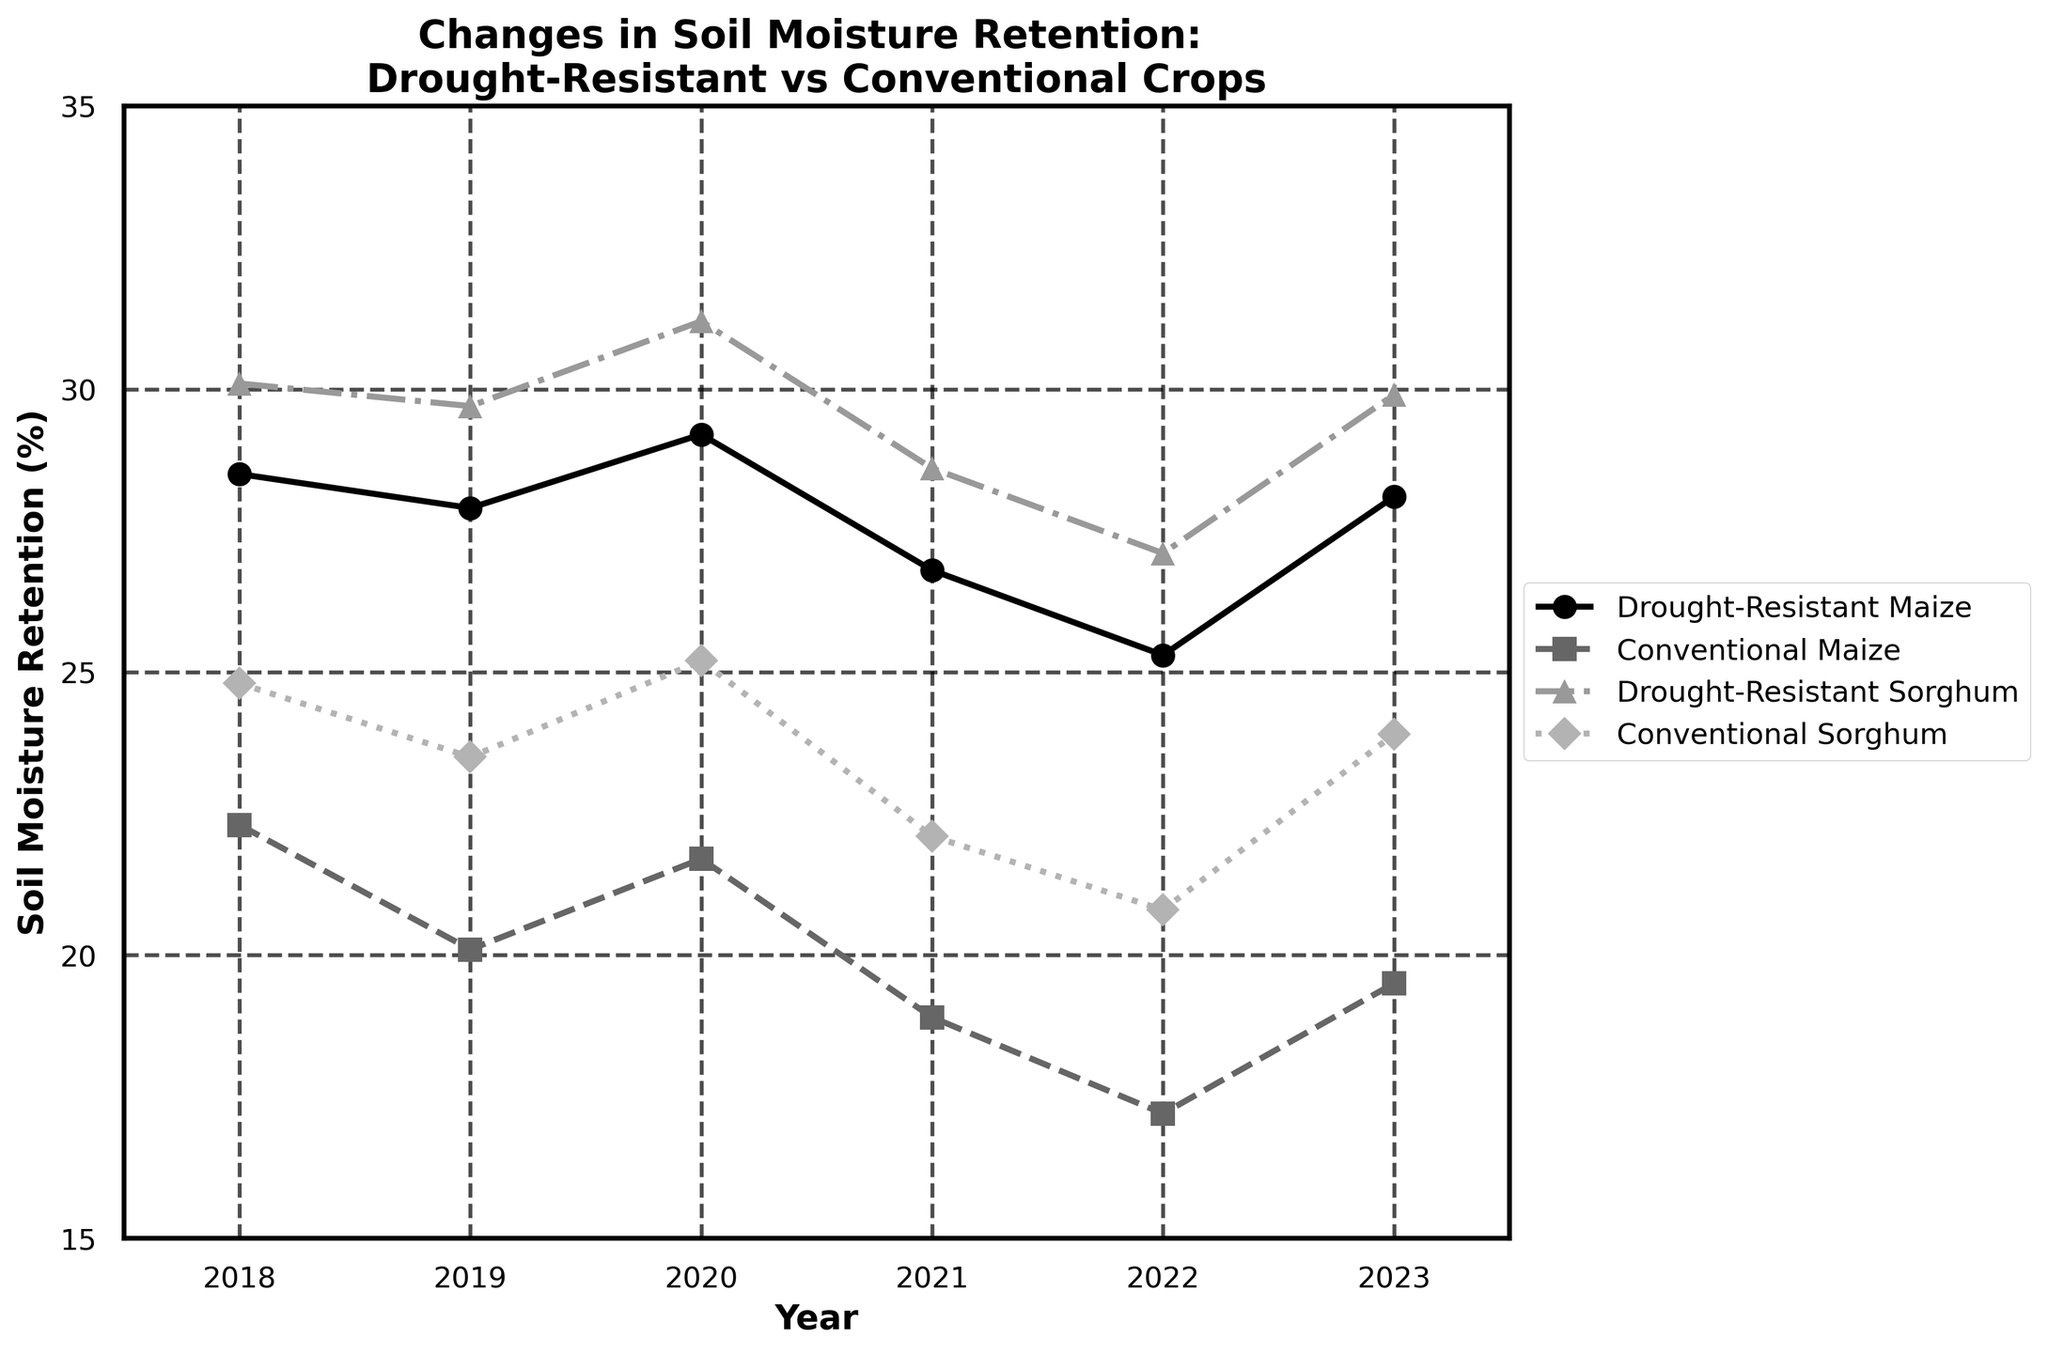What's the average soil moisture retention of Drought-Resistant Maize from 2018 to 2023? To find the average, sum all moisture retention values for Drought-Resistant Maize from 2018 to 2023 and divide by the number of years. The values are 28.5, 27.9, 29.2, 26.8, 25.3, and 28.1. Sum = 28.5 + 27.9 + 29.2 + 26.8 + 25.3 + 28.1 = 165.8. There are 6 measurements, so 165.8 / 6 = 27.63
Answer: 27.63 Which crop shows the highest soil moisture retention in 2023? Compare the 2023 values for all crops. The values are Drought-Resistant Maize (28.1), Conventional Maize (19.5), Drought-Resistant Sorghum (29.9), and Conventional Sorghum (23.9). Drought-Resistant Sorghum has the highest value.
Answer: Drought-Resistant Sorghum For which year is the difference in soil moisture retention between Drought-Resistant Maize and Conventional Maize the largest? Calculate the difference for each year, then determine the largest. Differences: 2018 (28.5 - 22.3 = 6.2), 2019 (27.9 - 20.1 = 7.8), 2020 (29.2 - 21.7 = 7.5), 2021 (26.8 - 18.9 = 7.9), 2022 (25.3 - 17.2 = 8.1), 2023 (28.1 - 19.5 = 8.6). The largest difference is in 2023.
Answer: 2023 What is the trend of soil moisture retention for Conventional Sorghum from 2018 to 2023? Analyze the values of Conventional Sorghum: 2018 (24.8), 2019 (23.5), 2020 (25.2), 2021 (22.1), 2022 (20.8), 2023 (23.9). The trend is generally decreasing from 2018 to 2022 with an increase in 2023.
Answer: Generally decreasing, then increasing in 2023 Which crop showed a decrease in soil moisture retention from 2018 to 2019? Compare 2018 and 2019 values for each crop. Drought-Resistant Maize (28.5 to 27.9), Conventional Maize (22.3 to 20.1), Drought-Resistant Sorghum (30.1 to 29.7), and Conventional Sorghum (24.8 to 23.5). All crops showed a decrease.
Answer: All crops By how much did soil moisture retention of Conventional Maize change from 2021 to 2022? Subtract the 2021 value from the 2022 value for Conventional Maize: 17.2 - 18.9 = -1.7. The retention decreased by 1.7.
Answer: Decreased by 1.7 Which year shows the highest overall soil moisture retention for all crops combined? Add all crop values for each year and find the highest sum: 2018 (105.7), 2019 (101.2), 2020 (107.3), 2021 (96.4), 2022 (90.4), 2023 (101.4). The highest overall retention is in 2020.
Answer: 2020 What's the median soil moisture retention value for Drought-Resistant Sorghum from 2018 to 2023? List the values: 30.1, 29.7, 31.2, 28.6, 27.1, 29.9. The median is the average of the middle two values in sorted order: 28.6, 29.7, 29.9, 30.1, 31.2. Median = (29.9 + 30.1) / 2 = 30
Answer: 30 How many times did Drought-Resistant Maize show a higher soil moisture retention than Conventional Sorghum in the examined years? Compare annual values of Drought-Resistant Maize and Conventional Sorghum: 2018 (28.5 < 30.1), 2019 (27.9 < 29.7), 2020 (29.2 < 31.2), 2021 (26.8 < 28.6), 2022 (25.3 < 27.1), 2023 (28.1 < 29.9). Drought-Resistant Maize never showed higher retention than Conventional Sorghum.
Answer: 0 times 